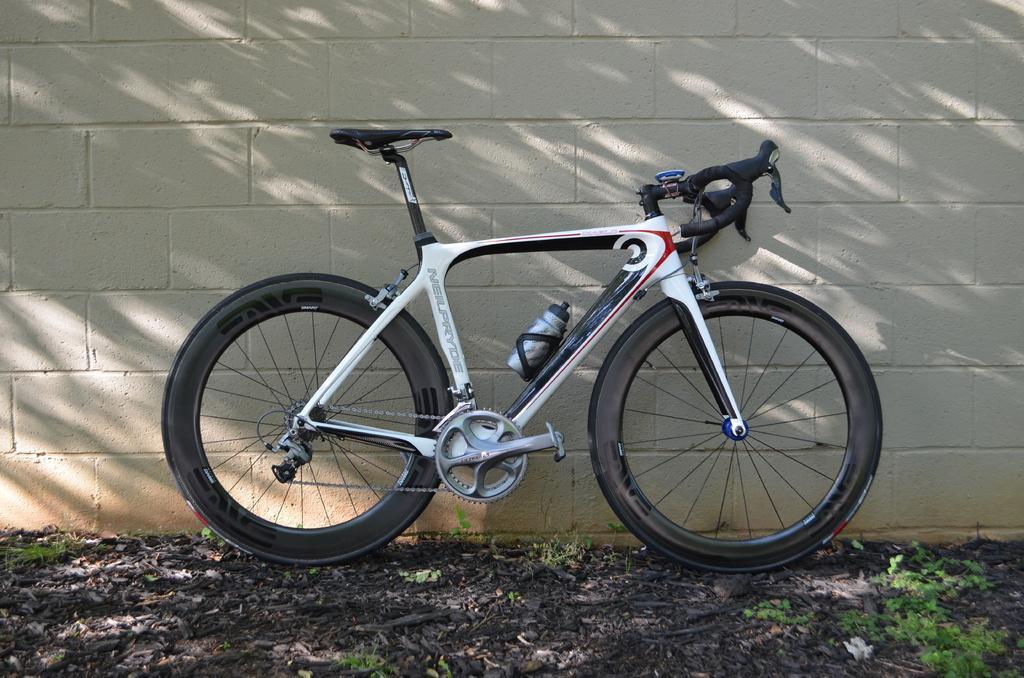Can you describe this image briefly? In this image in the center there is one cycle and in the cycle there is one bottle, at the bottom there is grass and some plants and in the background there is wall. 